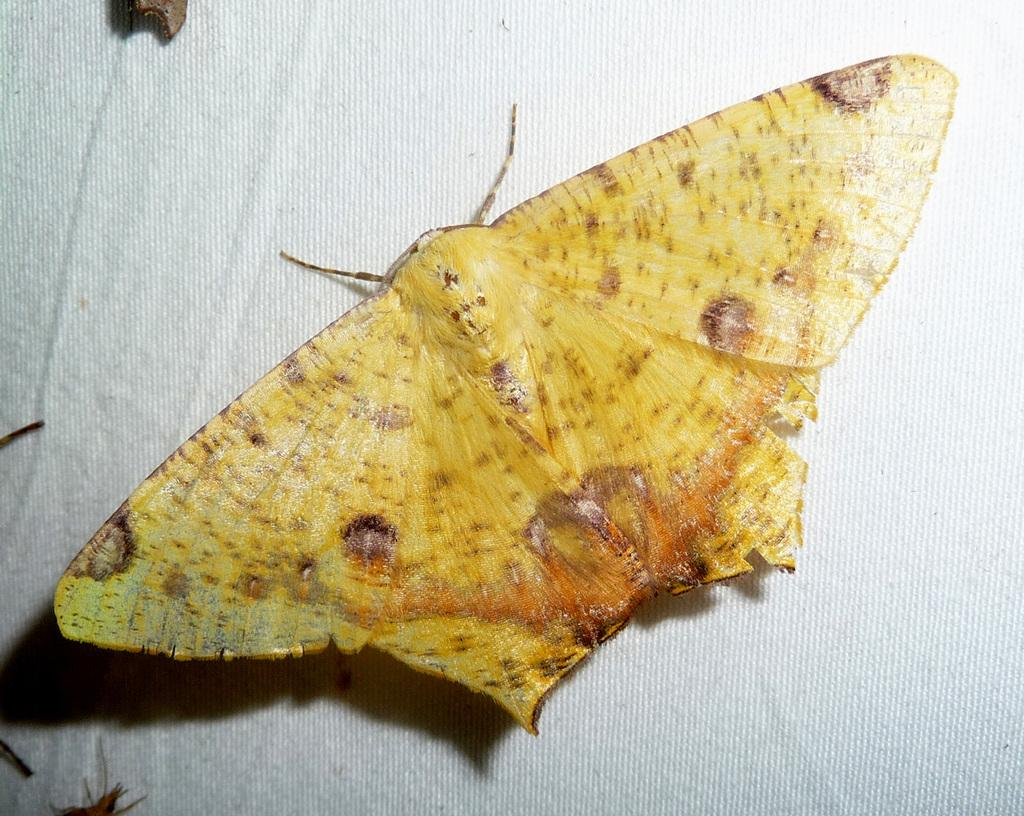What is present in the image? There is an insect in the image. Where is the insect located? The insect is on a white cloth. How many airports can be seen in the image? There are no airports present in the image. The image only features an insect on a white cloth. 